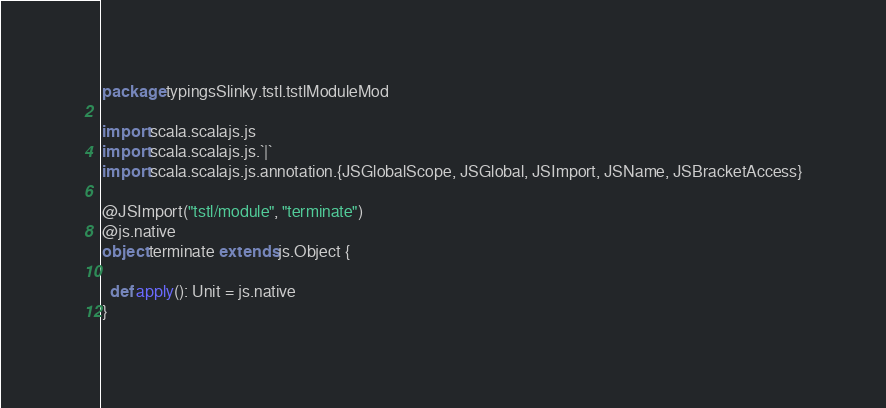<code> <loc_0><loc_0><loc_500><loc_500><_Scala_>package typingsSlinky.tstl.tstlModuleMod

import scala.scalajs.js
import scala.scalajs.js.`|`
import scala.scalajs.js.annotation.{JSGlobalScope, JSGlobal, JSImport, JSName, JSBracketAccess}

@JSImport("tstl/module", "terminate")
@js.native
object terminate extends js.Object {
  
  def apply(): Unit = js.native
}
</code> 